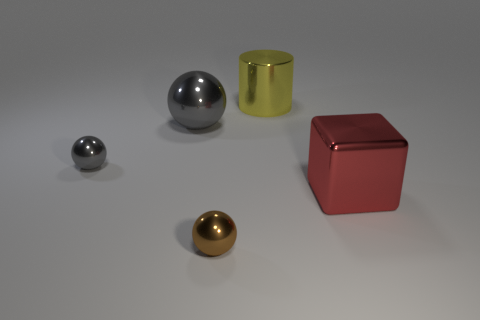Subtract all yellow blocks. How many gray balls are left? 2 Subtract all brown spheres. How many spheres are left? 2 Add 1 tiny cyan metal balls. How many objects exist? 6 Subtract all spheres. How many objects are left? 2 Subtract all purple spheres. Subtract all gray blocks. How many spheres are left? 3 Add 5 brown spheres. How many brown spheres exist? 6 Subtract 0 blue cubes. How many objects are left? 5 Subtract all small brown things. Subtract all red objects. How many objects are left? 3 Add 1 gray objects. How many gray objects are left? 3 